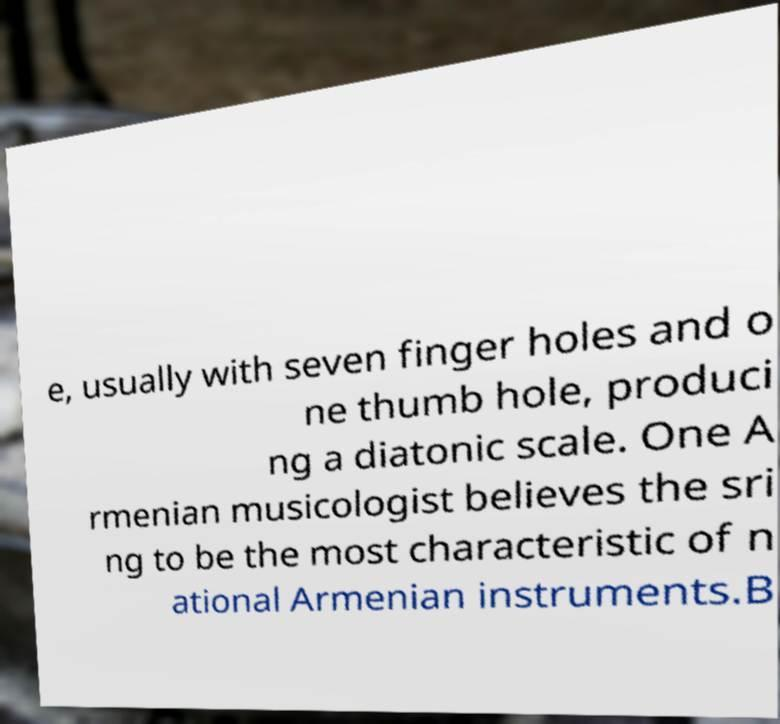Can you read and provide the text displayed in the image?This photo seems to have some interesting text. Can you extract and type it out for me? e, usually with seven finger holes and o ne thumb hole, produci ng a diatonic scale. One A rmenian musicologist believes the sri ng to be the most characteristic of n ational Armenian instruments.B 